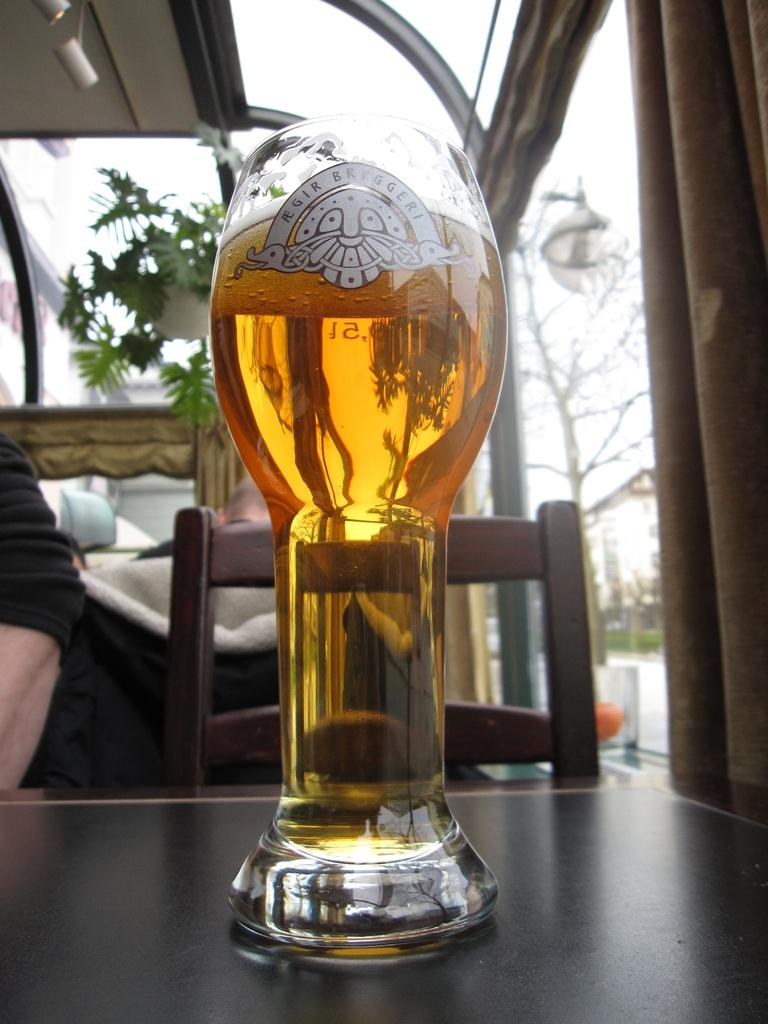What object is on the table in the image? There is a glass on the table in the image. What can be seen in the background of the image? There are people and a chair in the background of the image. What type of vegetation is present in the image? There is a green plant in the image. What is the color of the sky in the image? The sky appears to be white in color in the image. What type of doll is sitting on the chair in the image? There is no doll present in the image; it only features a glass on the table, people and a chair in the background, a green plant, and a white sky. 